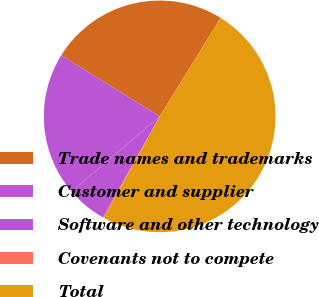Convert chart to OTSL. <chart><loc_0><loc_0><loc_500><loc_500><pie_chart><fcel>Trade names and trademarks<fcel>Customer and supplier<fcel>Software and other technology<fcel>Covenants not to compete<fcel>Total<nl><fcel>24.98%<fcel>20.08%<fcel>5.62%<fcel>0.17%<fcel>49.16%<nl></chart> 